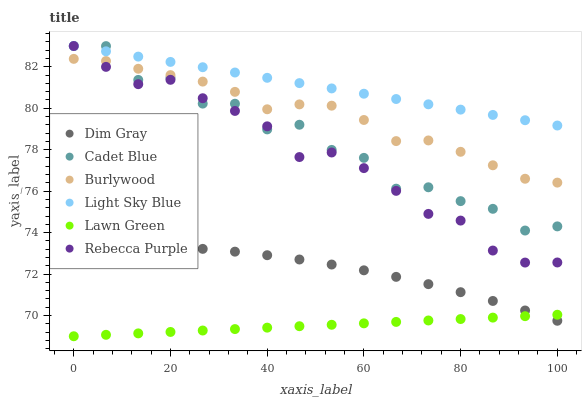Does Lawn Green have the minimum area under the curve?
Answer yes or no. Yes. Does Light Sky Blue have the maximum area under the curve?
Answer yes or no. Yes. Does Cadet Blue have the minimum area under the curve?
Answer yes or no. No. Does Cadet Blue have the maximum area under the curve?
Answer yes or no. No. Is Light Sky Blue the smoothest?
Answer yes or no. Yes. Is Cadet Blue the roughest?
Answer yes or no. Yes. Is Burlywood the smoothest?
Answer yes or no. No. Is Burlywood the roughest?
Answer yes or no. No. Does Lawn Green have the lowest value?
Answer yes or no. Yes. Does Cadet Blue have the lowest value?
Answer yes or no. No. Does Light Sky Blue have the highest value?
Answer yes or no. Yes. Does Burlywood have the highest value?
Answer yes or no. No. Is Dim Gray less than Rebecca Purple?
Answer yes or no. Yes. Is Light Sky Blue greater than Burlywood?
Answer yes or no. Yes. Does Light Sky Blue intersect Rebecca Purple?
Answer yes or no. Yes. Is Light Sky Blue less than Rebecca Purple?
Answer yes or no. No. Is Light Sky Blue greater than Rebecca Purple?
Answer yes or no. No. Does Dim Gray intersect Rebecca Purple?
Answer yes or no. No. 